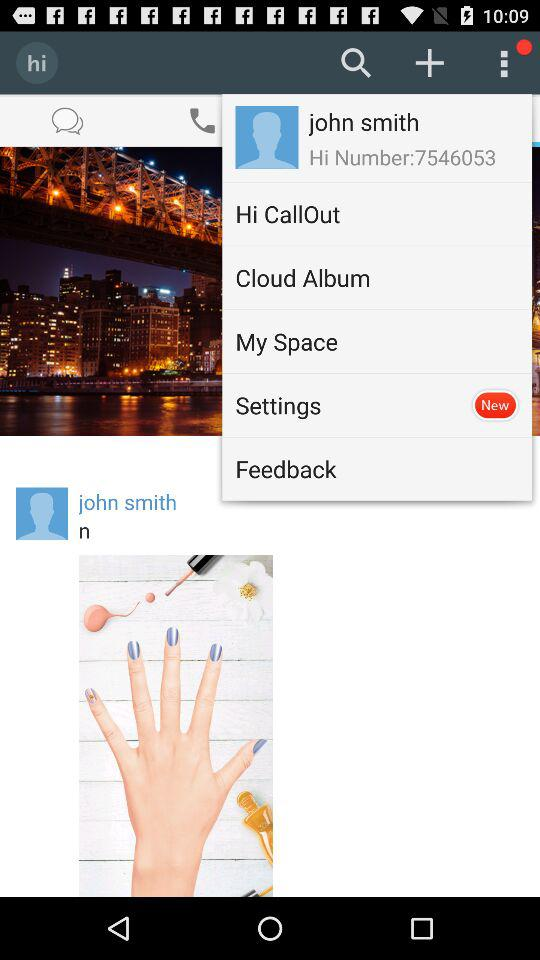What item has a new update in the application? The item "Settings" has a new update in the application. 